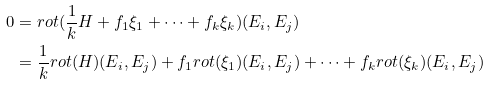<formula> <loc_0><loc_0><loc_500><loc_500>0 & = r o t ( \frac { 1 } { k } H + f _ { 1 } \xi _ { 1 } + \dots + f _ { k } \xi _ { k } ) ( E _ { i } , E _ { j } ) \\ & = \frac { 1 } { k } r o t ( H ) ( E _ { i } , E _ { j } ) + f _ { 1 } r o t ( \xi _ { 1 } ) ( E _ { i } , E _ { j } ) + \dots + f _ { k } r o t ( \xi _ { k } ) ( E _ { i } , E _ { j } )</formula> 